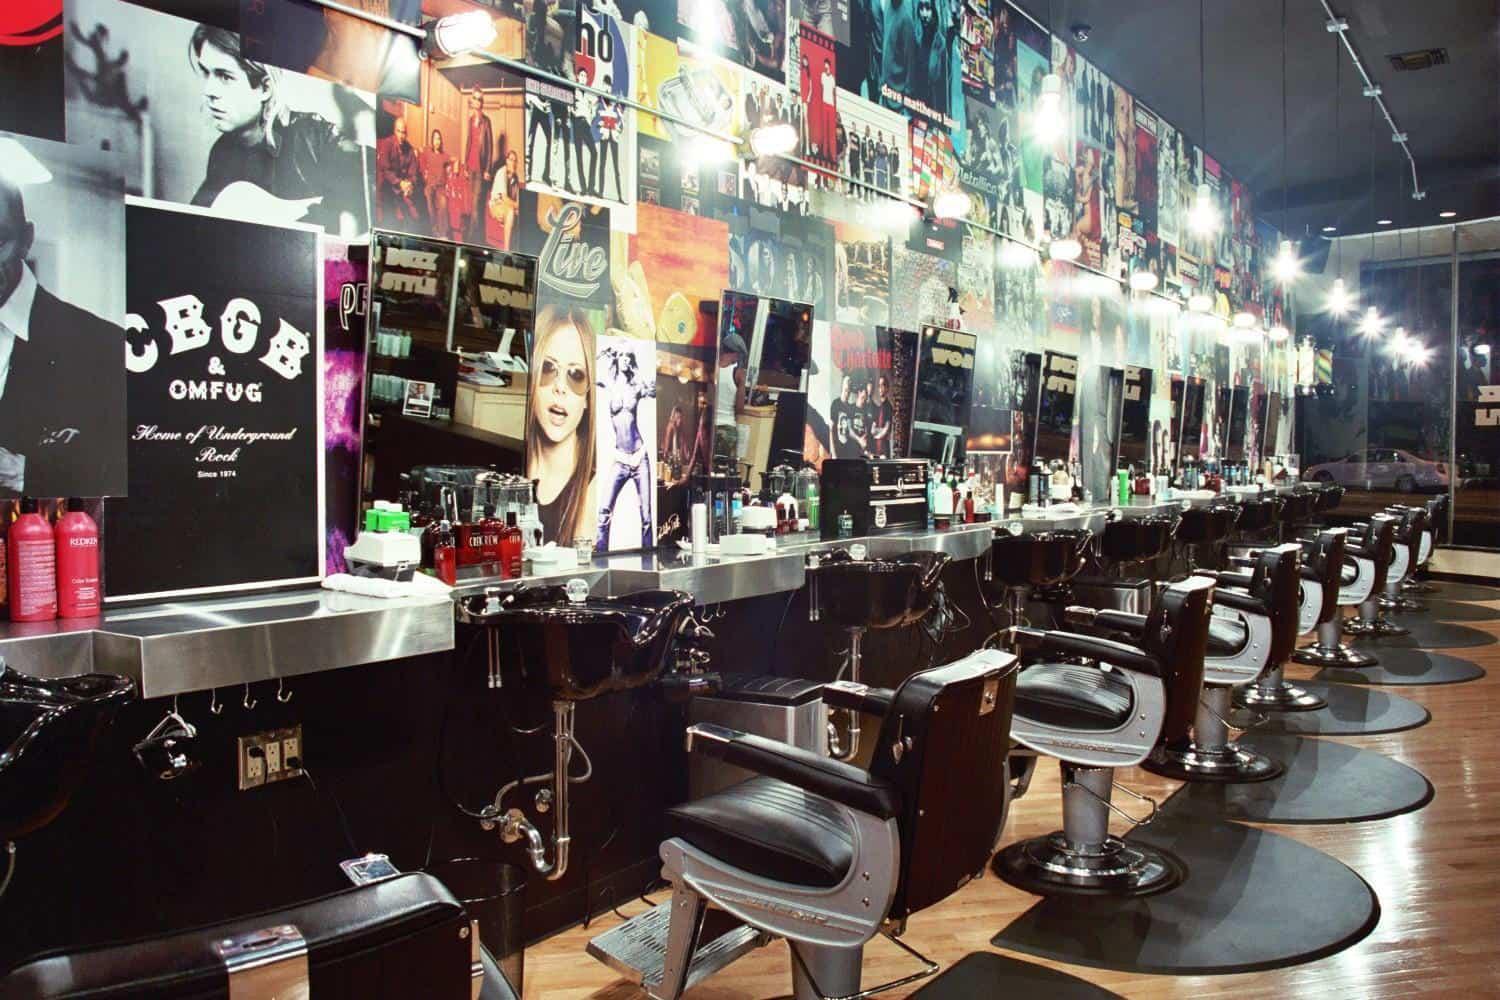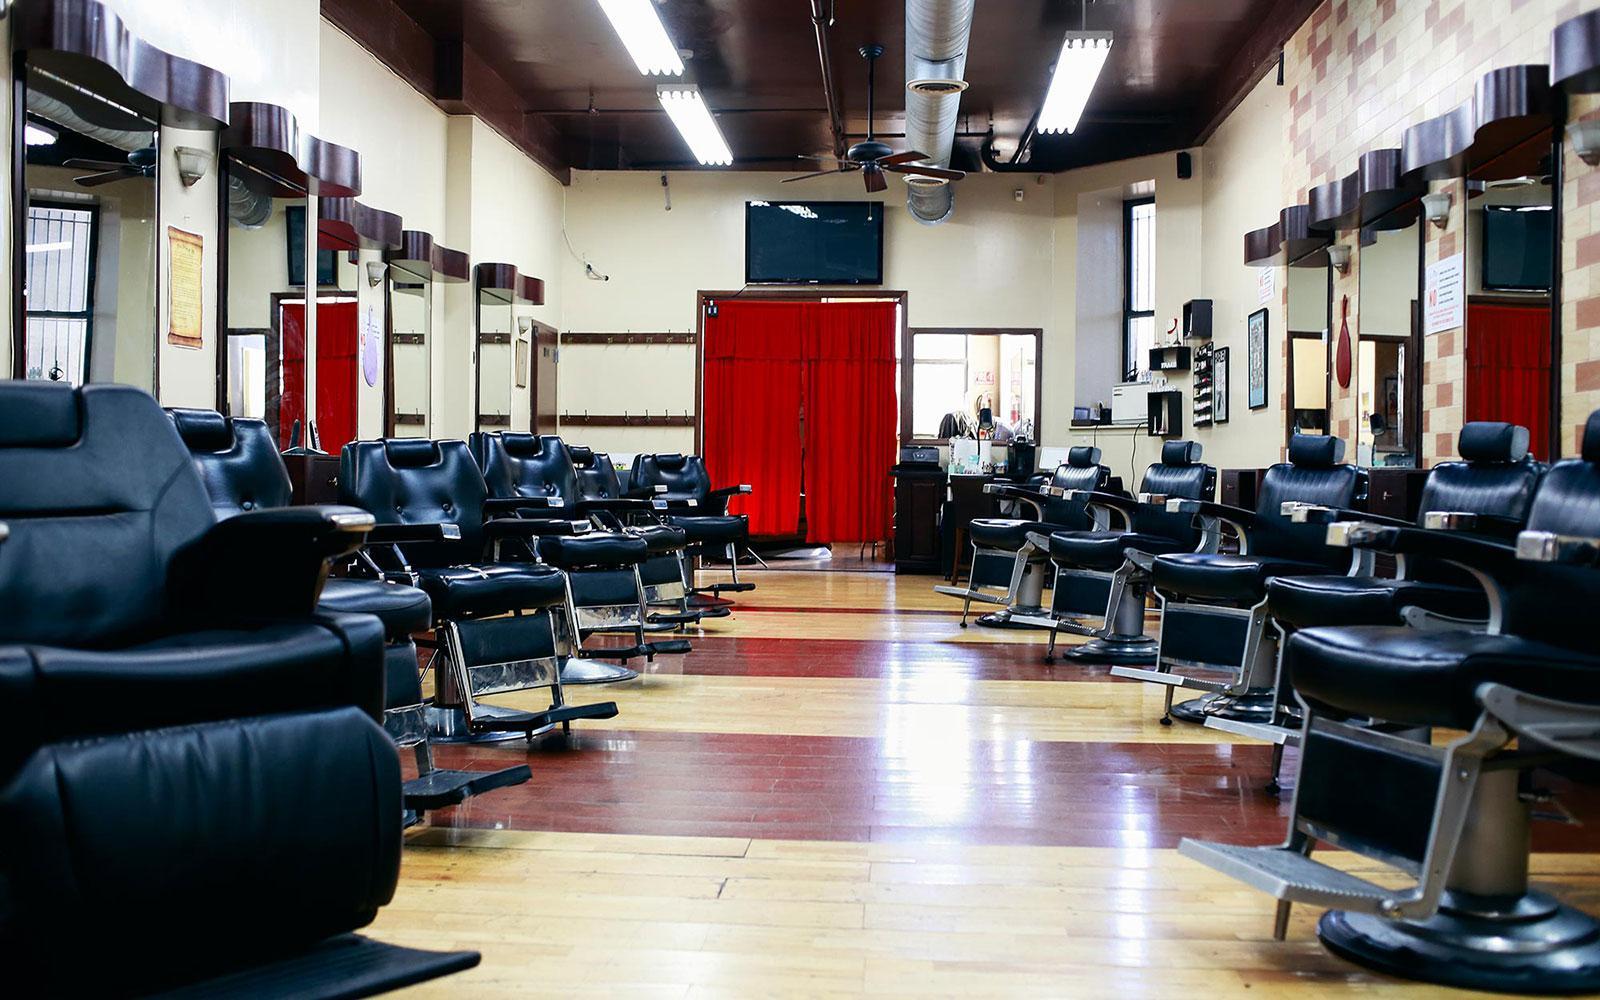The first image is the image on the left, the second image is the image on the right. Considering the images on both sides, is "There are at least two people in the image on the right." valid? Answer yes or no. No. 